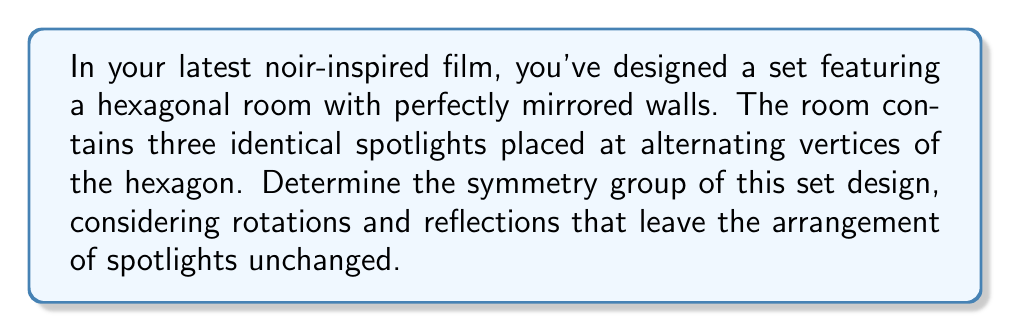What is the answer to this math problem? To determine the symmetry group of this set design, we need to consider the symmetries that preserve the arrangement of the spotlights within the hexagonal room. Let's approach this step-by-step:

1. Identify the symmetries:
   a) Rotational symmetries: The design has rotational symmetry of order 2, as rotating by 120° or 240° will result in the same arrangement of spotlights.
   b) Reflection symmetries: There are three lines of reflection, each passing through the center of the hexagon and bisecting two opposite sides.

2. Count the elements of the symmetry group:
   - Identity transformation (e)
   - Two rotations: 120° clockwise (r) and 240° clockwise (r²)
   - Three reflections (s₁, s₂, s₃)

   Total number of elements: 1 + 2 + 3 = 6

3. Identify the group:
   The group has 6 elements and contains both rotations and reflections. This structure matches the dihedral group of order 6, denoted as $D_6$ or $D_3$ (depending on the notation system).

4. Verify the group properties:
   - Closure: Combining any two symmetries results in another symmetry of the design.
   - Associativity: This is inherent in geometric transformations.
   - Identity: The identity transformation e leaves the design unchanged.
   - Inverse: Each transformation has an inverse (e.g., r² is the inverse of r, and each reflection is its own inverse).

5. Group presentation:
   The dihedral group $D_3$ can be presented as:
   $$D_3 = \langle r, s | r^3 = s^2 = e, srs = r^{-1} \rangle$$

   Where r represents the 120° rotation and s represents any of the reflections.

This group captures the noir-inspired interplay of light and shadow in your set design, reflecting the symmetrical yet mysterious nature of the film noir genre.
Answer: The symmetry group of the film noir-inspired set design is the dihedral group $D_3$ (or $D_6$), of order 6. 